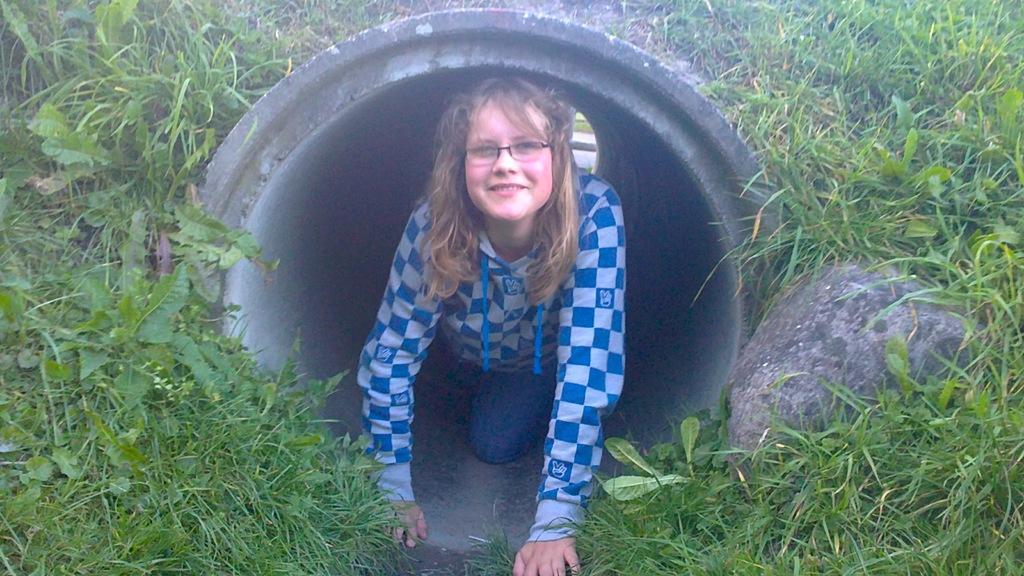In one or two sentences, can you explain what this image depicts? In this image in the center there is one woman who is smiling, and she is in pipe and on the right side there is a rock. And there are some plants and grass. 